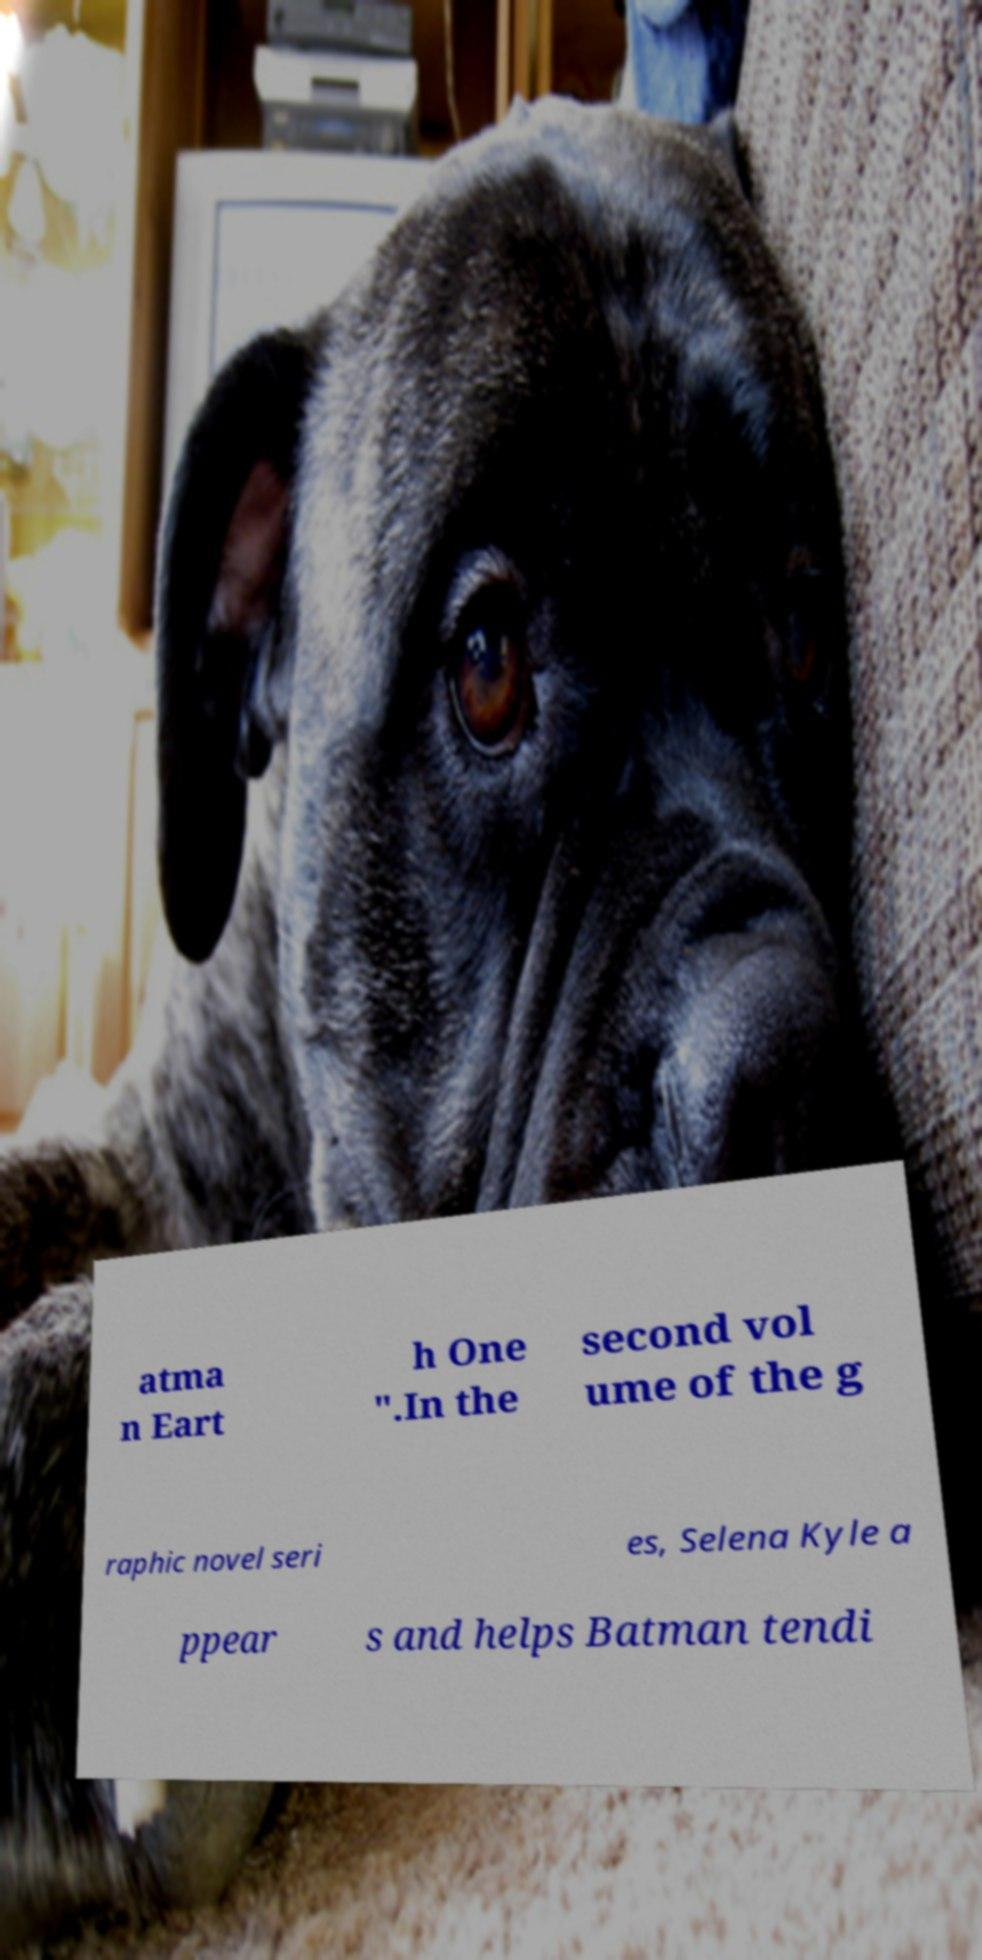Could you assist in decoding the text presented in this image and type it out clearly? atma n Eart h One ".In the second vol ume of the g raphic novel seri es, Selena Kyle a ppear s and helps Batman tendi 